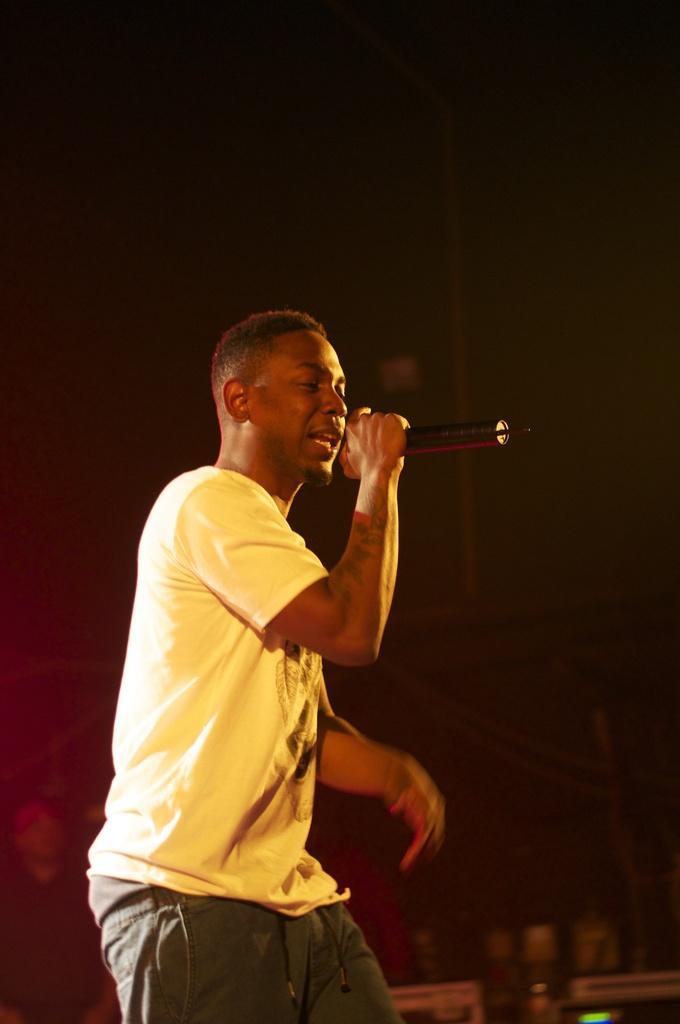Please provide a concise description of this image. I can see in this image a man wearing yellow color t-shirt holding a microphone in his hand 